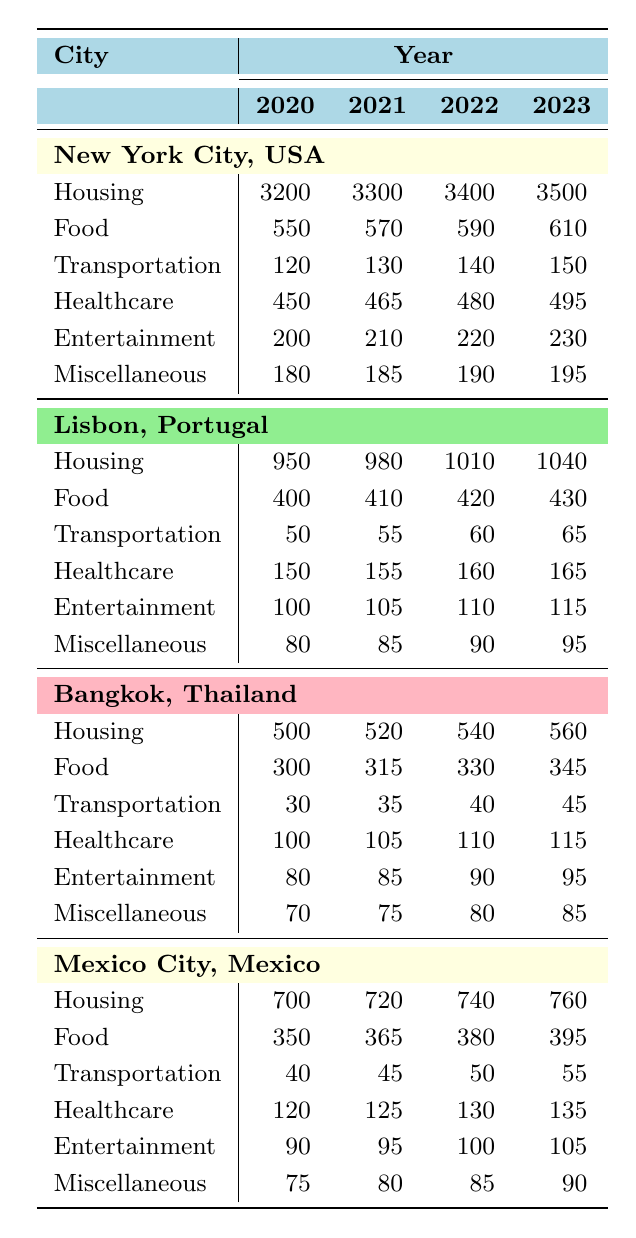What were the housing expenses in New York City for retirees in 2022? According to the table, the housing expenses in New York City for retirees in 2022 were 3400.
Answer: 3400 What is the total cost of food in Portugal from 2020 to 2023? To find the total cost of food in Portugal, we sum the yearly expenses: 400 + 410 + 420 + 430 = 1660.
Answer: 1660 Did transportation costs in Bangkok increase every year from 2020 to 2023? By checking the table, the transportation costs in Bangkok were 30, 35, 40, and 45 for the respective years, which indicates a consistent increase each year.
Answer: Yes What was the average healthcare expense for retirees in Mexico City over the four years? The healthcare expenses in Mexico City for the years 2020 to 2023 were 120, 125, 130, and 135. Adding these gives 120 + 125 + 130 + 135 = 510, and dividing by 4 (the number of years) gives an average of 510 / 4 = 127.5.
Answer: 127.5 In which year did New York City have the highest miscellaneous expenses? The table shows New York City's miscellaneous expenses were 180, 185, 190, and 195 from 2020 to 2023. The highest value is 195, which corresponds to the year 2023.
Answer: 2023 What were the entertainment expenses for retirees in Thailand in 2021 compared to 2023? The entertainment expenses in Thailand were 85 in 2021 and 95 in 2023, indicating an increase of 10.
Answer: 10 Is the total living expense in Lisbon, Portugal higher than in Bangkok, Thailand in 2023? The total living expenses in Lisbon in 2023 were obtained by summing 1040 (housing), 430 (food), 65 (transportation), 165 (healthcare), 115 (entertainment), and 95 (miscellaneous), giving 2010. In Bangkok, the total was 560 + 345 + 45 + 115 + 95 + 85 = 1145. Since 2010 > 1145, Lisbon's total is higher.
Answer: Yes What is the difference in housing expenses between Mexico City in 2020 and Lisbon in 2023? The housing expense in Mexico City in 2020 was 700, while in Lisbon in 2023 it was 1040. The difference is 1040 - 700 = 340.
Answer: 340 Which city had the lowest total expenses on food across the four years? The food expenses for each city were New York City (2020 to 2023: 550, 570, 590, 610 = 2520), Lisbon (2020 to 2023: 400, 410, 420, 430 = 1660), Bangkok (300, 315, 330, 345 = 1290), and Mexico City (350, 365, 380, 395 = 1490). Comparing totals, Bangkok had the lowest total food expenses.
Answer: Bangkok 